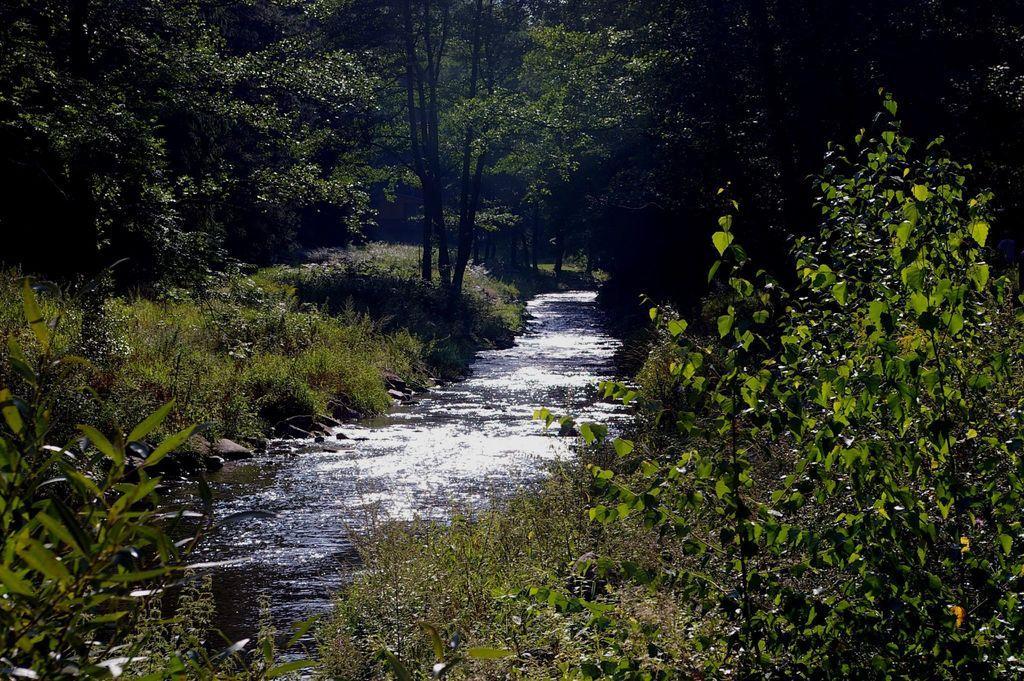How would you summarize this image in a sentence or two? In this picture we can see water in the middle, at the bottom there are some plants, in the background we can see trees. 